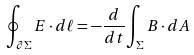<formula> <loc_0><loc_0><loc_500><loc_500>\oint _ { \partial \Sigma } E \cdot d { \ell } = - { \frac { d } { d t } } { \int _ { \Sigma } B \cdot d A }</formula> 